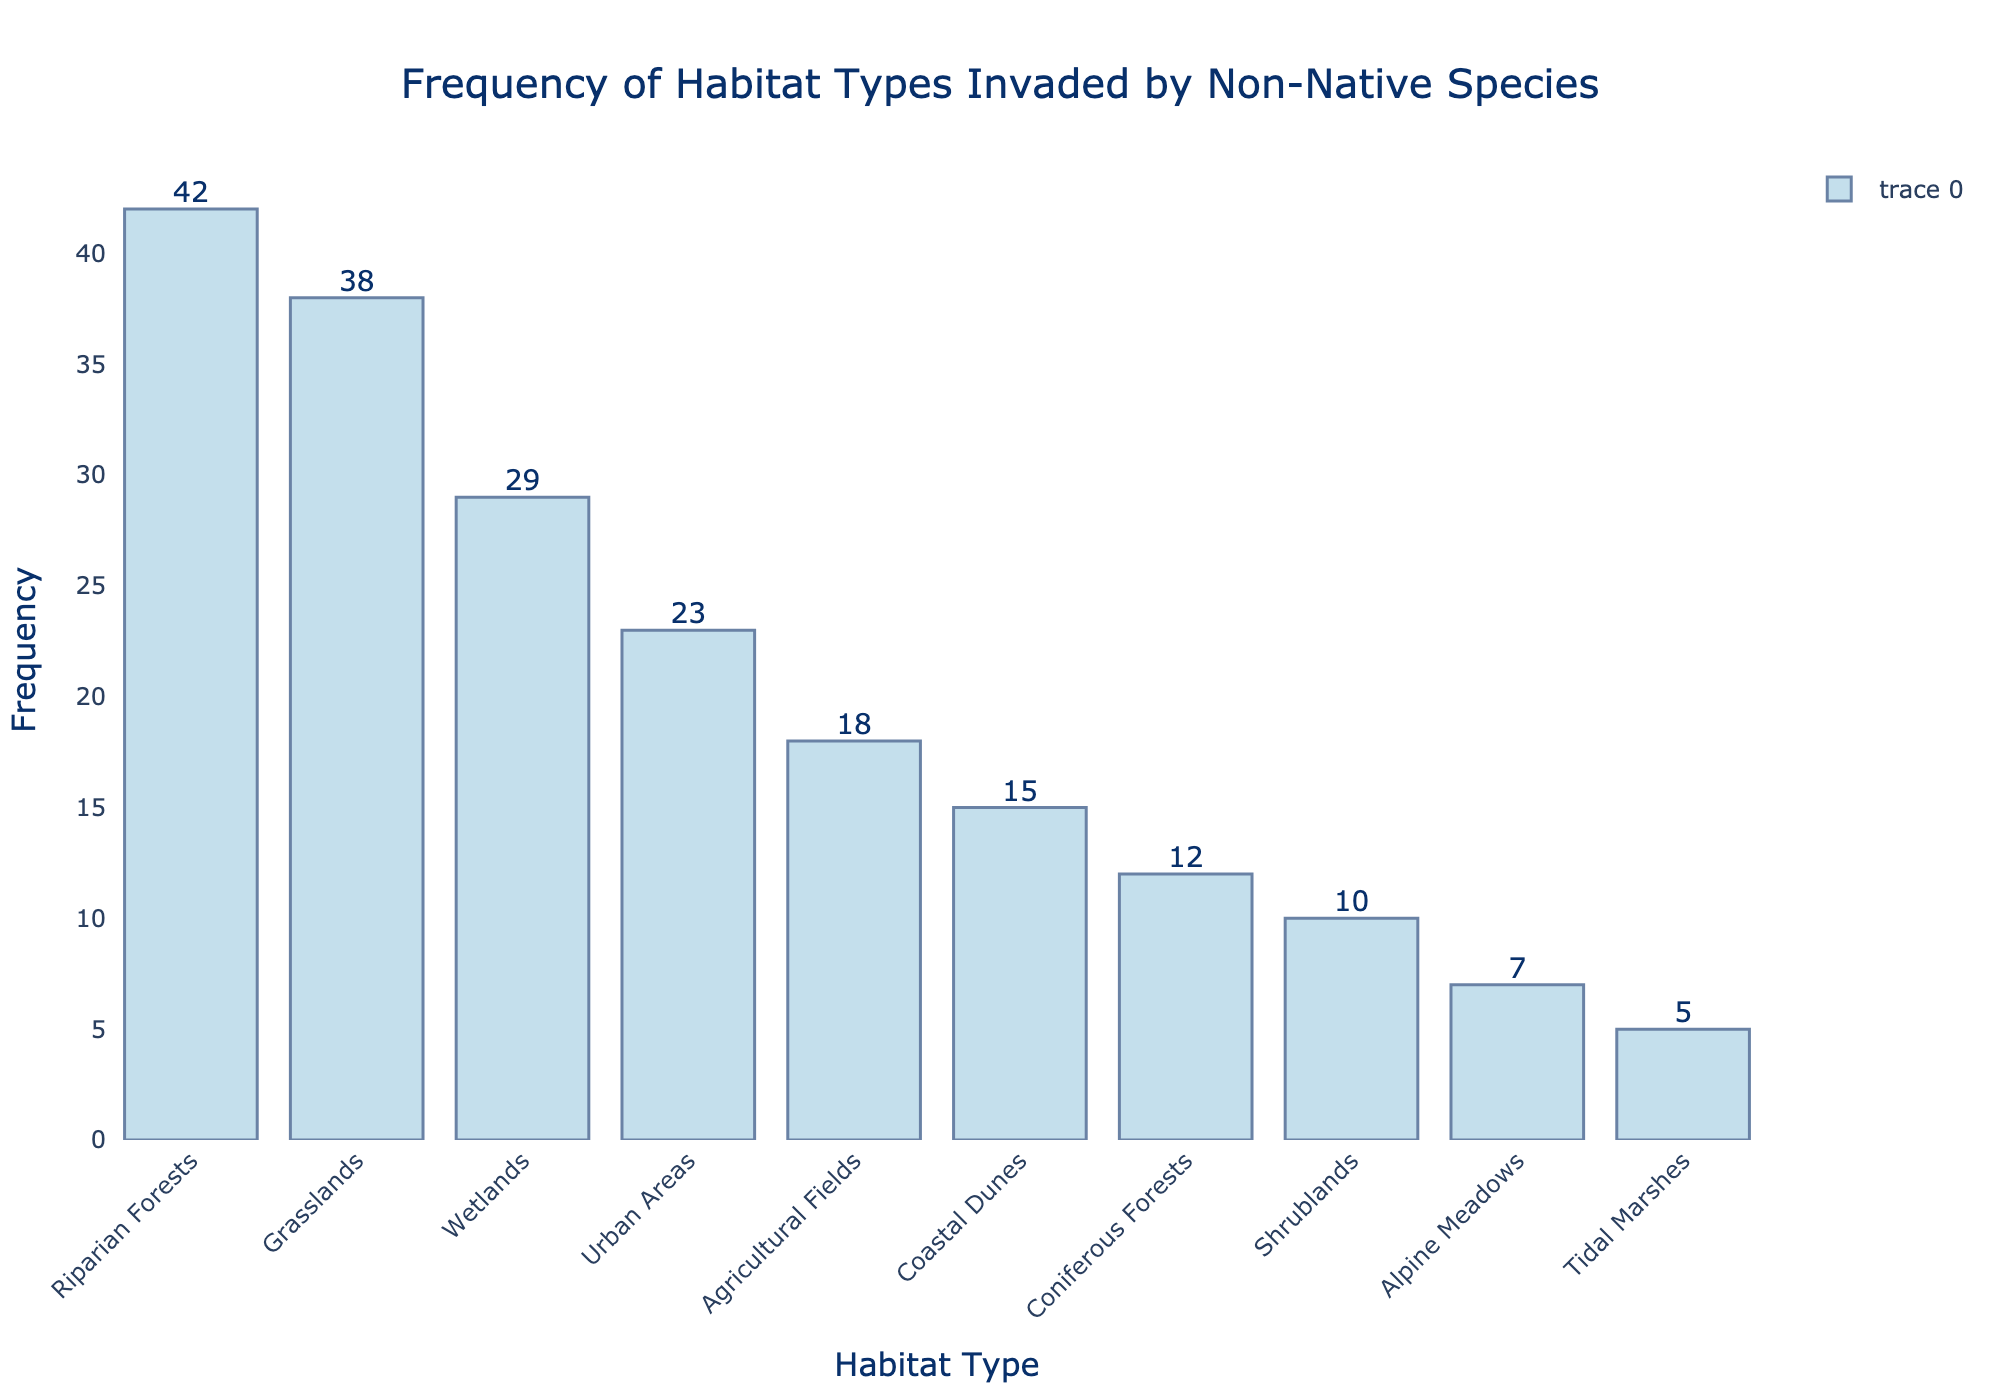What is the title of the histogram? The title is usually placed at the top of the figure and provides an overview of what the chart represents. In this case, the title is central, in a font that is larger and more prominent than the other text elements.
Answer: Frequency of Habitat Types Invaded by Non-Native Species Which habitat type has the highest frequency of invasion? By observing the height of the bars in the histogram, we can see which one reaches the highest point along the y-axis, indicating the highest frequency.
Answer: Riparian Forests What is the frequency of Coastal Dunes being invaded? Locate the Coastal Dunes label on the x-axis, then move upward to see where the bar ends. The number at the top of the bar or on the y-axis corresponds to the frequency.
Answer: 15 Which habitat type has the lowest frequency of invasion, and how many invasions does it have? Find the shortest bar among all the bars. The habitat type at the bottom of this bar is the one with the lowest frequency.
Answer: Tidal Marshes have 5 invasions What is the difference in the number of invasions between Grasslands and Wetlands? First, identify the frequencies for both Grasslands and Wetlands from their respective bars (Grasslands: 38, Wetlands: 29). Subtract the smaller frequency from the larger one.
Answer: The difference is 9 How many total habitat types are shown in the histogram? Count the number of distinct bars or the number of labels on the x-axis. This represents the different habitat types.
Answer: 10 Which habitat has more invasions: Urban Areas or Agricultural Fields, and by how many? Identify the frequencies of both Urban Areas (23) and Agricultural Fields (18) from their respective bars. Subtract the smaller number from the larger one.
Answer: Urban Areas have 5 more invasions What is the average frequency of invasions across all habitat types? Add up the frequencies of all habitats and divide by the number of habitat types (sum = 199, number of habitats = 10). The average is the sum divided by the total number of habitats.
Answer: The average frequency is 19.9 How many habitat types have invasions greater than 20? Count the number of bars that extend above the 20 mark on the y-axis.
Answer: 4 Which three habitats have the highest invasion frequencies, and what are these frequencies? Identify the three bars that reach the highest points on the y-axis. These are the top three habitats by frequency.
Answer: Riparian Forests (42), Grasslands (38), Wetlands (29) 